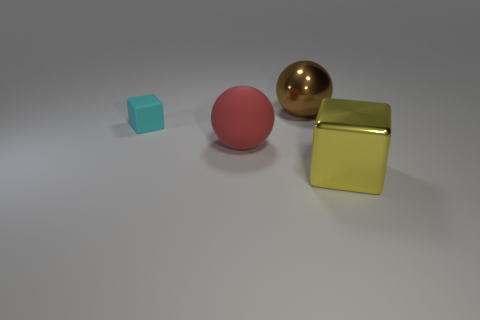What are the materials that the objects in the image seem to be made of? The objects appear to be made of different materials: the leftmost object has a matte cyan surface resembling plastic, the central object has a smooth, matte finish suggestive of a rubber-like material, and the two objects on the right seem metallic, with the golden one being reflective and the cube having a shiny, perhaps brushed metal texture. 